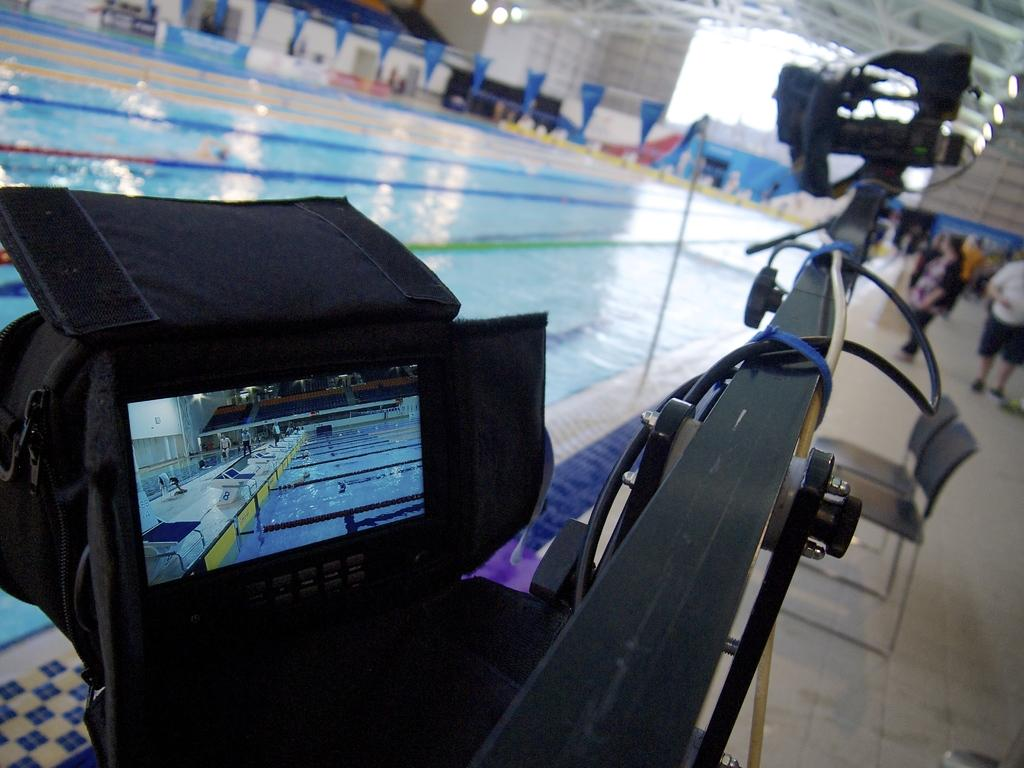What is the main object in the image? There is a screen in the image. What else can be seen in the image besides the screen? There are chairs, wires, water, flags, people standing on a platform, and a wall visible in the background of the image. Can you describe the lighting conditions in the image? There are lights visible in the background of the image. What type of mark can be seen on the loaf of bread in the image? There is no loaf of bread present in the image, so it is not possible to determine if there is a mark on it. 